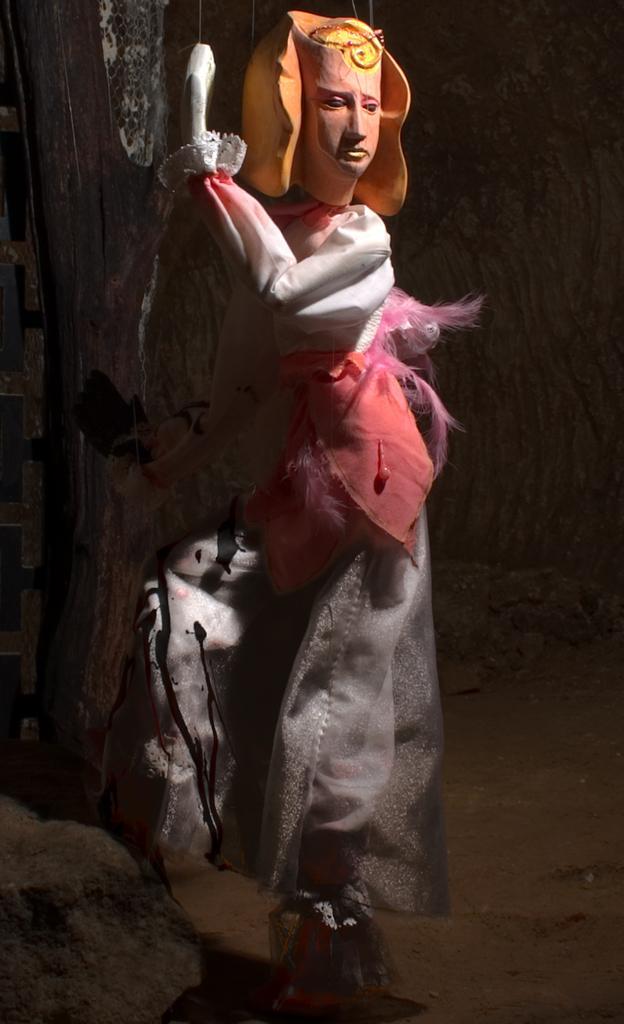How would you summarize this image in a sentence or two? This is the picture of a sculptor to which there is a different costume and to the side there is a rock. 